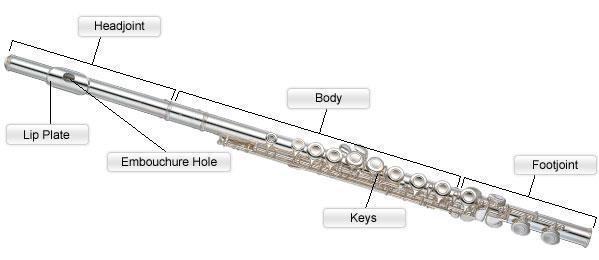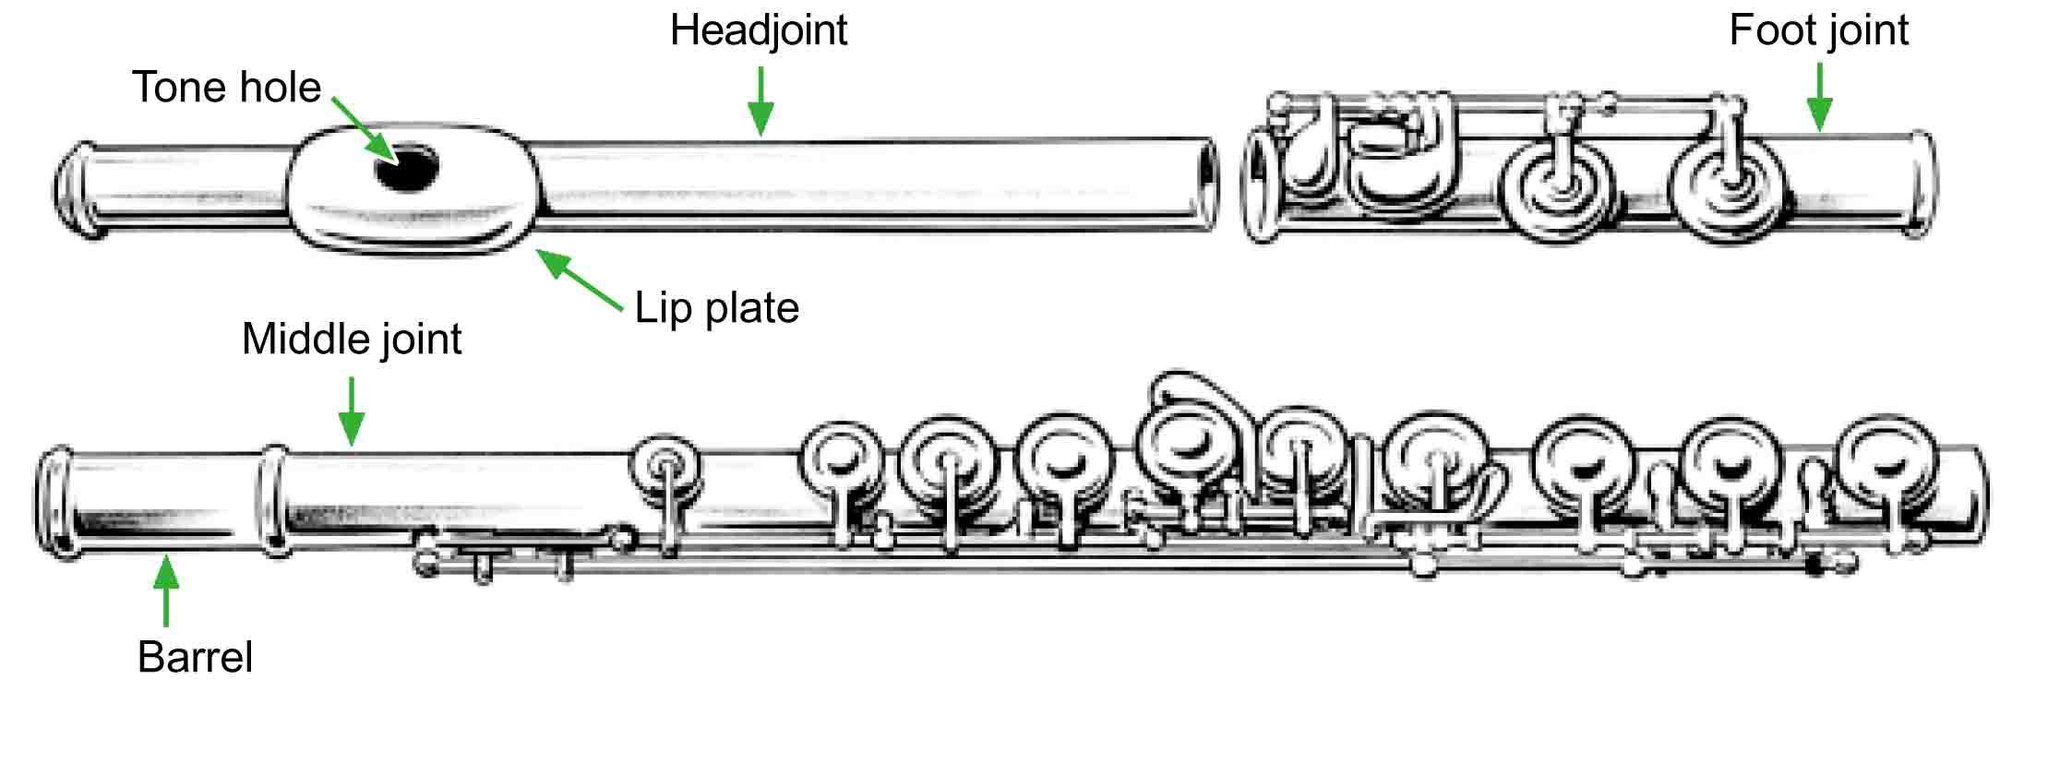The first image is the image on the left, the second image is the image on the right. For the images shown, is this caption "There are two flute illustrations in the right image." true? Answer yes or no. Yes. The first image is the image on the left, the second image is the image on the right. For the images shown, is this caption "The left and right image contains a total of three flutes." true? Answer yes or no. Yes. 